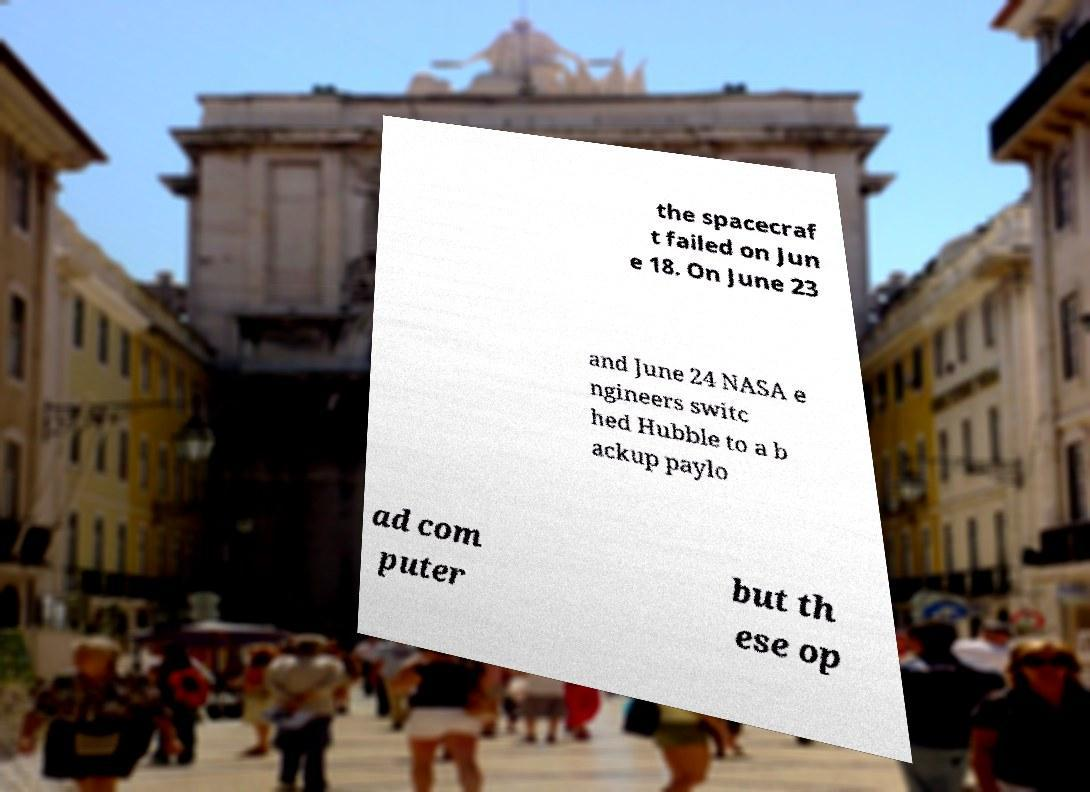Could you assist in decoding the text presented in this image and type it out clearly? the spacecraf t failed on Jun e 18. On June 23 and June 24 NASA e ngineers switc hed Hubble to a b ackup paylo ad com puter but th ese op 